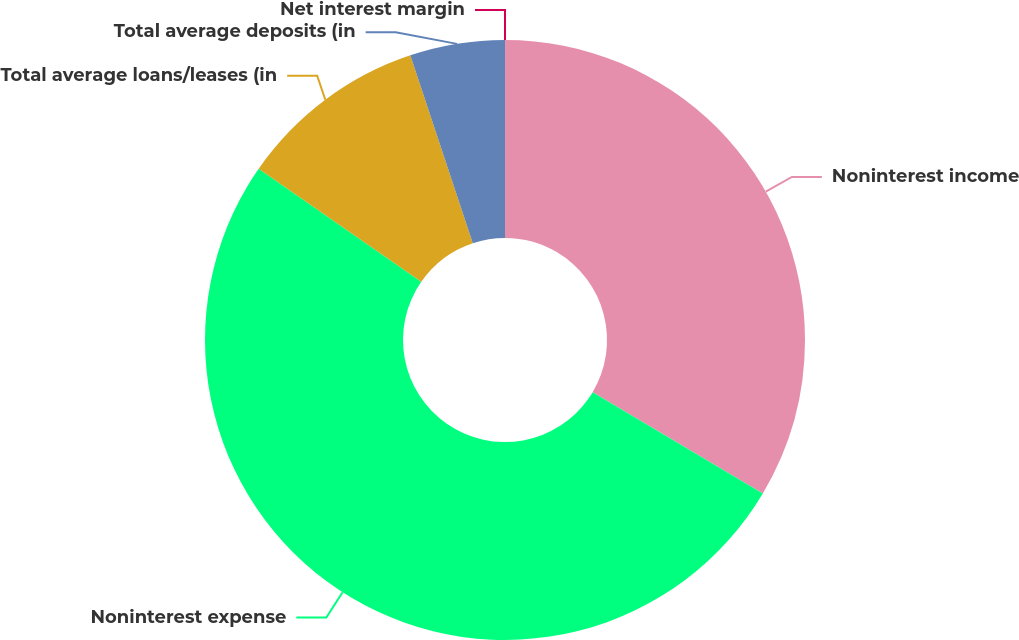Convert chart. <chart><loc_0><loc_0><loc_500><loc_500><pie_chart><fcel>Noninterest income<fcel>Noninterest expense<fcel>Total average loans/leases (in<fcel>Total average deposits (in<fcel>Net interest margin<nl><fcel>33.54%<fcel>51.12%<fcel>10.22%<fcel>5.11%<fcel>0.0%<nl></chart> 